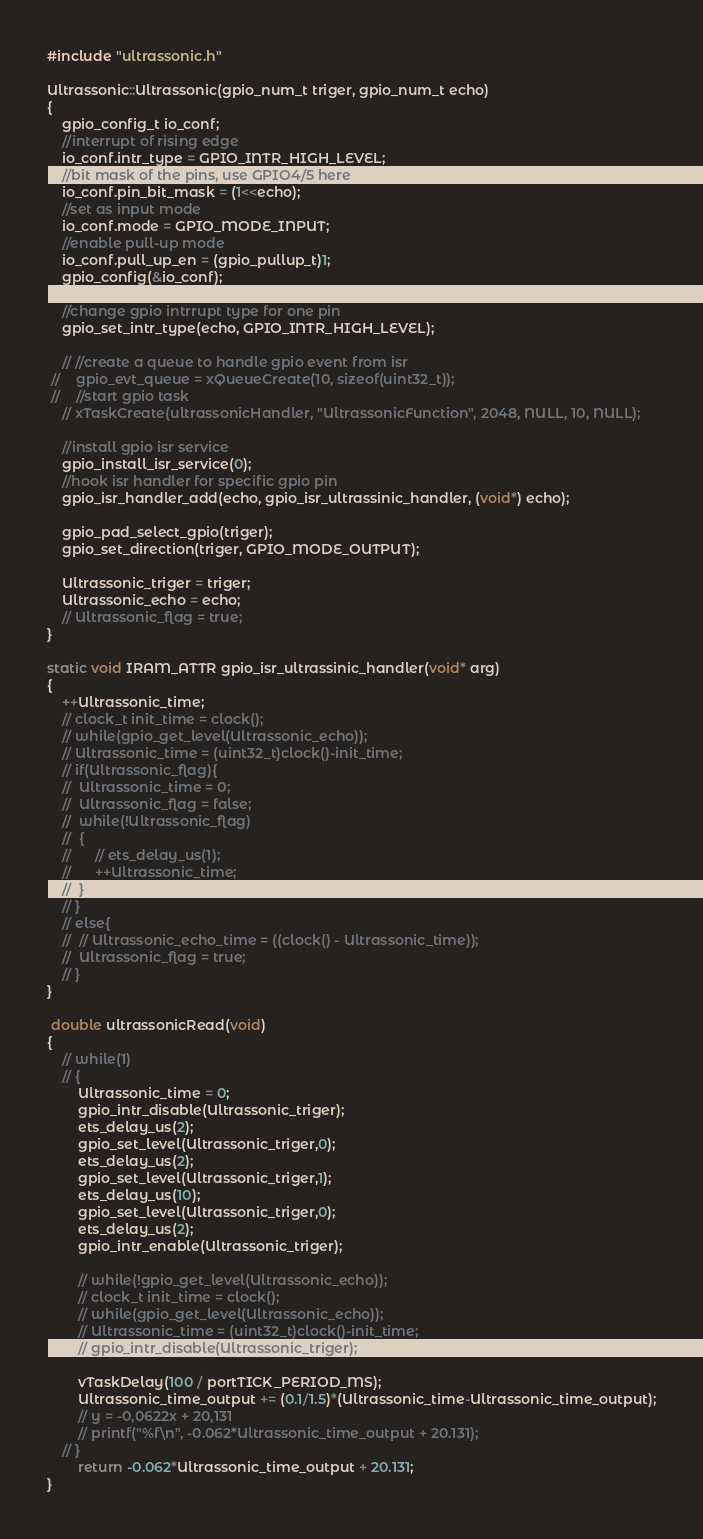<code> <loc_0><loc_0><loc_500><loc_500><_C++_>#include "ultrassonic.h"

Ultrassonic::Ultrassonic(gpio_num_t triger, gpio_num_t echo)
{
	gpio_config_t io_conf;
	//interrupt of rising edge
    io_conf.intr_type = GPIO_INTR_HIGH_LEVEL;
    //bit mask of the pins, use GPIO4/5 here
    io_conf.pin_bit_mask = (1<<echo);
    //set as input mode    
    io_conf.mode = GPIO_MODE_INPUT;
    //enable pull-up mode
    io_conf.pull_up_en = (gpio_pullup_t)1;
    gpio_config(&io_conf);

    //change gpio intrrupt type for one pin
	gpio_set_intr_type(echo, GPIO_INTR_HIGH_LEVEL);

	// //create a queue to handle gpio event from isr
 //    gpio_evt_queue = xQueueCreate(10, sizeof(uint32_t));
 //    //start gpio task
    // xTaskCreate(ultrassonicHandler, "UltrassonicFunction", 2048, NULL, 10, NULL);

    //install gpio isr service
    gpio_install_isr_service(0);
    //hook isr handler for specific gpio pin
	gpio_isr_handler_add(echo, gpio_isr_ultrassinic_handler, (void*) echo);

	gpio_pad_select_gpio(triger);
    gpio_set_direction(triger, GPIO_MODE_OUTPUT);

    Ultrassonic_triger = triger;
    Ultrassonic_echo = echo;
    // Ultrassonic_flag = true;
}

static void IRAM_ATTR gpio_isr_ultrassinic_handler(void* arg)
{
	++Ultrassonic_time;
	// clock_t init_time = clock();
	// while(gpio_get_level(Ultrassonic_echo));	
	// Ultrassonic_time = (uint32_t)clock()-init_time;
	// if(Ultrassonic_flag){
	// 	Ultrassonic_time = 0;
	// 	Ultrassonic_flag = false;
	// 	while(!Ultrassonic_flag)
	// 	{
	// 		// ets_delay_us(1);
	// 		++Ultrassonic_time;
	// 	}
	// }
	// else{
	// 	// Ultrassonic_echo_time = ((clock() - Ultrassonic_time));
	// 	Ultrassonic_flag = true;
	// }
}

 double ultrassonicRead(void)
{
	// while(1)
	// {
		Ultrassonic_time = 0;
		gpio_intr_disable(Ultrassonic_triger);
		ets_delay_us(2);
		gpio_set_level(Ultrassonic_triger,0);
		ets_delay_us(2);
		gpio_set_level(Ultrassonic_triger,1);
		ets_delay_us(10);
		gpio_set_level(Ultrassonic_triger,0);
		ets_delay_us(2);
		gpio_intr_enable(Ultrassonic_triger);

		// while(!gpio_get_level(Ultrassonic_echo));
		// clock_t init_time = clock();
		// while(gpio_get_level(Ultrassonic_echo));
		// Ultrassonic_time = (uint32_t)clock()-init_time;
		// gpio_intr_disable(Ultrassonic_triger);

		vTaskDelay(100 / portTICK_PERIOD_MS);
		Ultrassonic_time_output += (0.1/1.5)*(Ultrassonic_time-Ultrassonic_time_output);
		// y = -0,0622x + 20,131
		// printf("%f\n", -0.062*Ultrassonic_time_output + 20.131);
	// }
		return -0.062*Ultrassonic_time_output + 20.131;
}</code> 